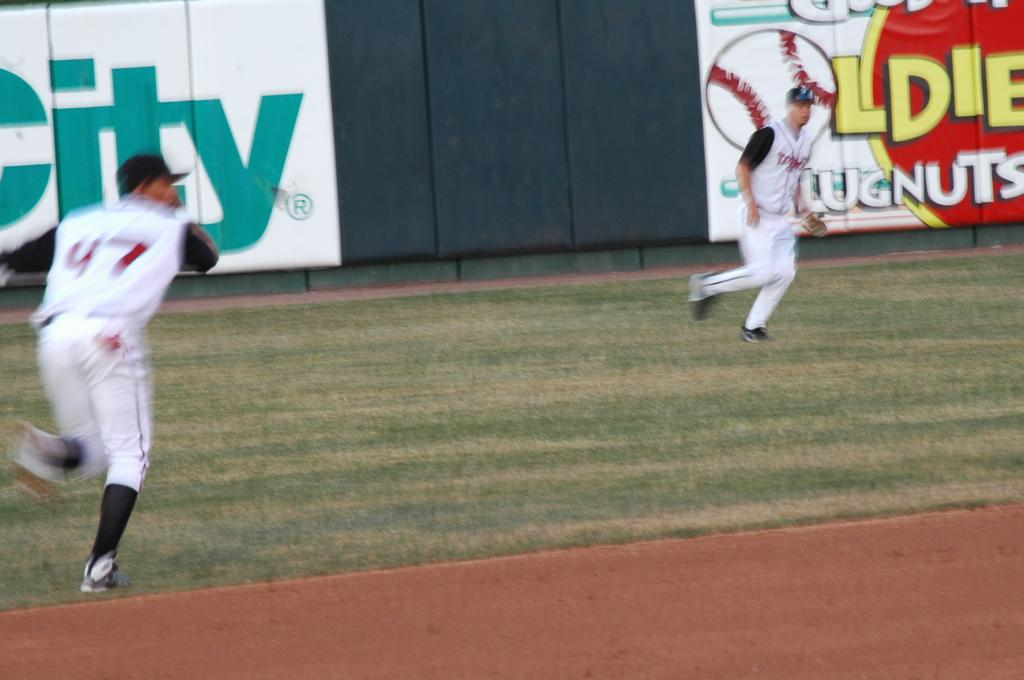<image>
Share a concise interpretation of the image provided. Two baseball players with a sign in the back showing the letters ITY 